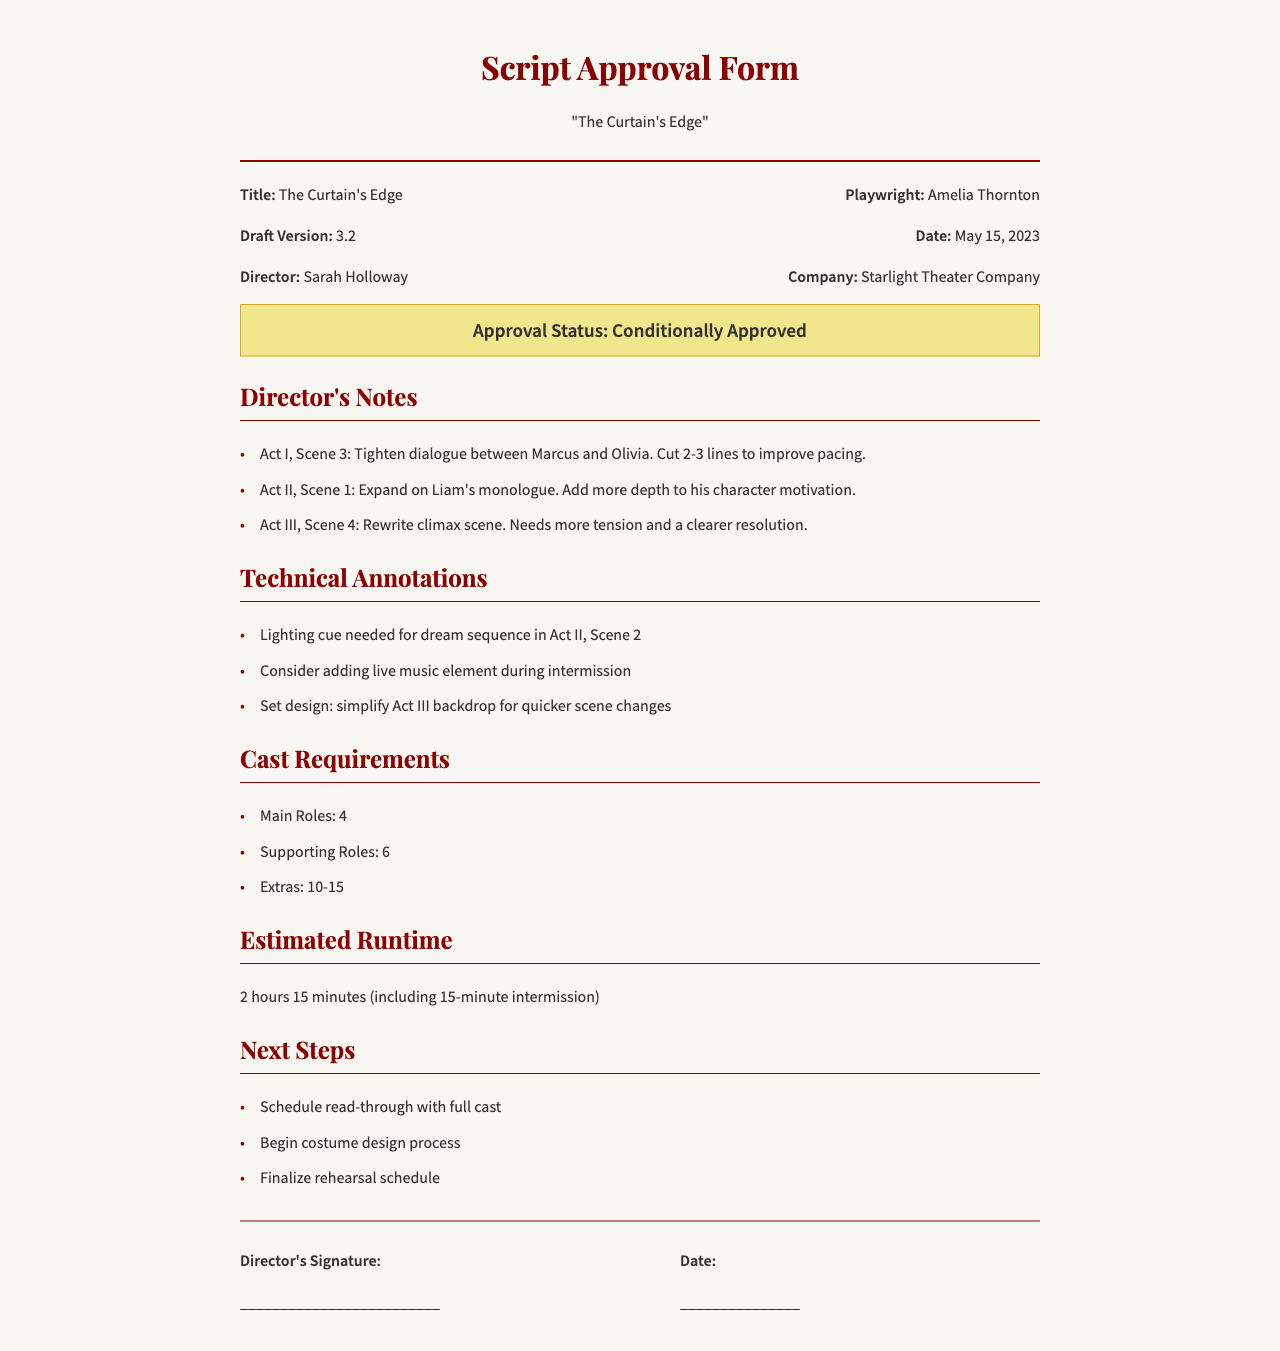What is the title of the play? The title is the main subject of the document, clearly stated at the top.
Answer: The Curtain's Edge Who is the playwright? This information is provided next to the title in the play information section.
Answer: Amelia Thornton What is the approval status of the script? The approval status is highlighted in a specific section of the document.
Answer: Conditionally Approved How many main roles are required? This number is specified under the section detailing cast requirements.
Answer: 4 What is the estimated runtime of the play? The estimated runtime is mentioned in a distinct section dedicated to runtime details.
Answer: 2 hours 15 minutes In which act and scene should the climax be rewritten? The act and scene for the rewrite is noted in the director's notes.
Answer: Act III, Scene 4 What is the date on the script approval form? The date is mentioned in the play information section along with other details.
Answer: May 15, 2023 What needs to be scheduled for the next steps? The next steps include specific tasks listed in the document.
Answer: Read-through with full cast What type of cue is needed for a scene in Act II? A specific cue type is outlined under technical annotations for scene requirements.
Answer: Lighting cue 